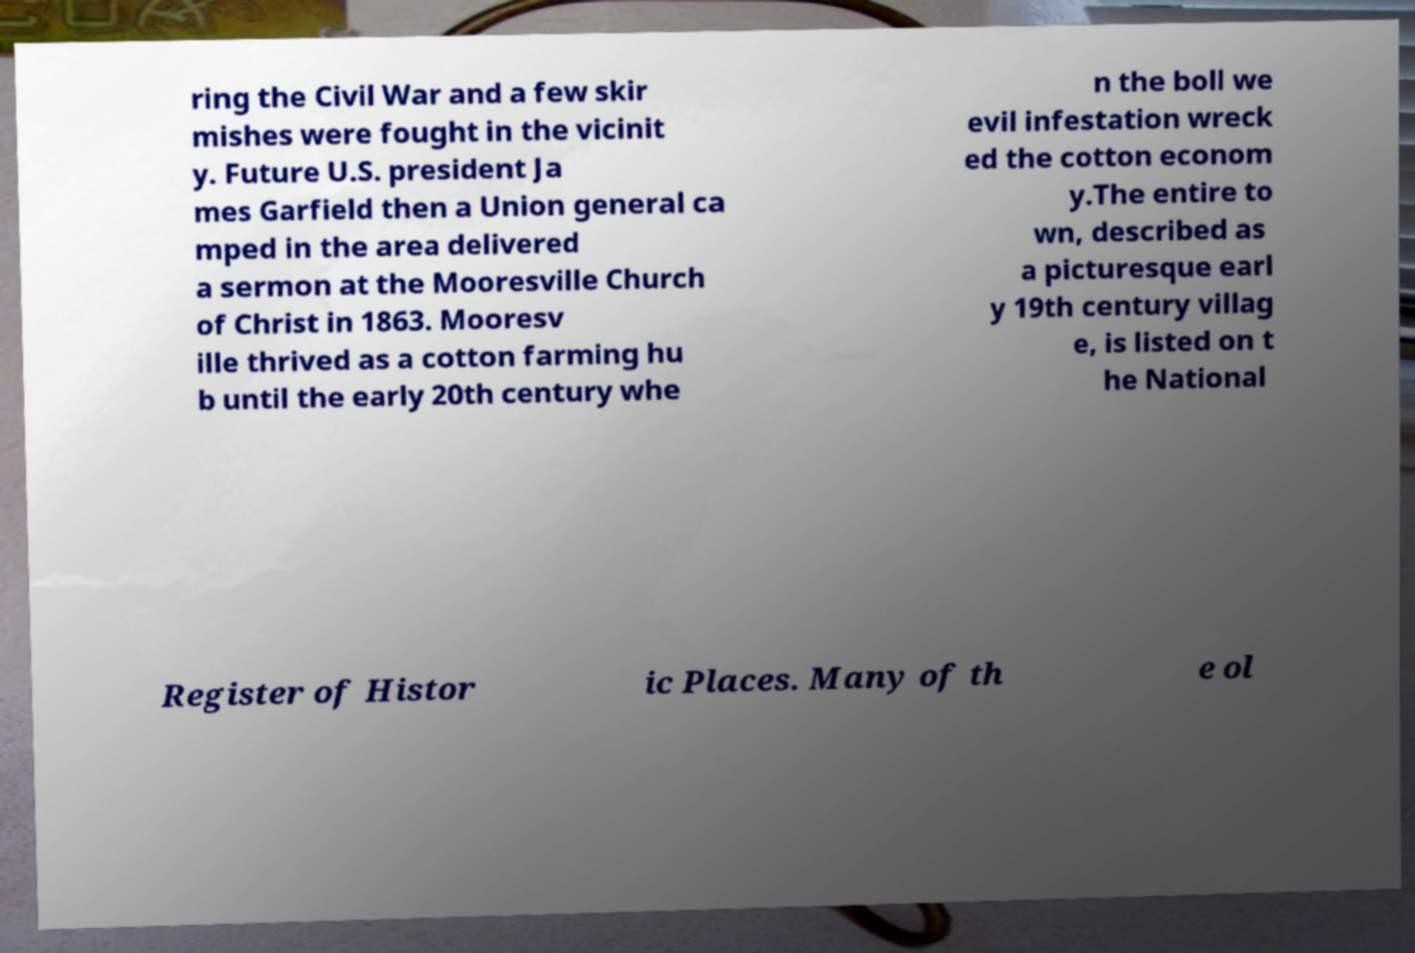I need the written content from this picture converted into text. Can you do that? ring the Civil War and a few skir mishes were fought in the vicinit y. Future U.S. president Ja mes Garfield then a Union general ca mped in the area delivered a sermon at the Mooresville Church of Christ in 1863. Mooresv ille thrived as a cotton farming hu b until the early 20th century whe n the boll we evil infestation wreck ed the cotton econom y.The entire to wn, described as a picturesque earl y 19th century villag e, is listed on t he National Register of Histor ic Places. Many of th e ol 